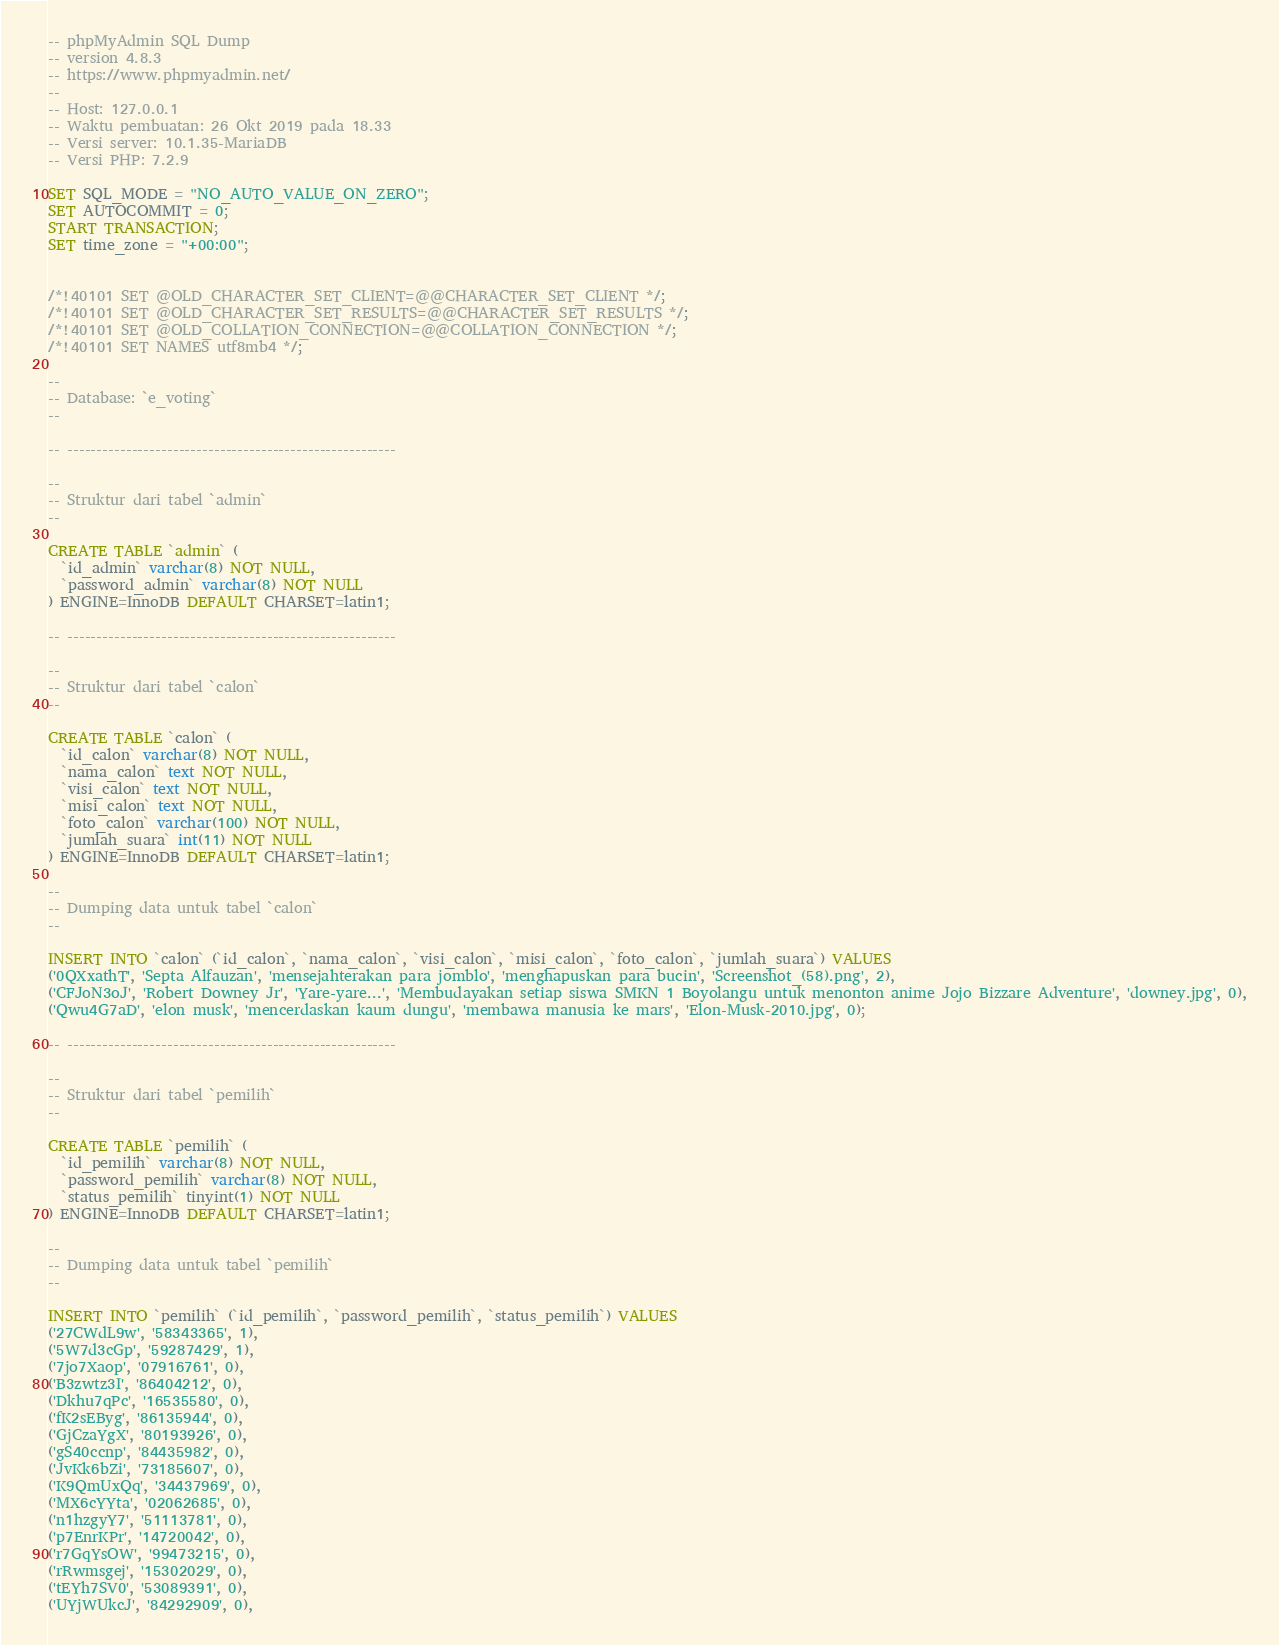Convert code to text. <code><loc_0><loc_0><loc_500><loc_500><_SQL_>-- phpMyAdmin SQL Dump
-- version 4.8.3
-- https://www.phpmyadmin.net/
--
-- Host: 127.0.0.1
-- Waktu pembuatan: 26 Okt 2019 pada 18.33
-- Versi server: 10.1.35-MariaDB
-- Versi PHP: 7.2.9

SET SQL_MODE = "NO_AUTO_VALUE_ON_ZERO";
SET AUTOCOMMIT = 0;
START TRANSACTION;
SET time_zone = "+00:00";


/*!40101 SET @OLD_CHARACTER_SET_CLIENT=@@CHARACTER_SET_CLIENT */;
/*!40101 SET @OLD_CHARACTER_SET_RESULTS=@@CHARACTER_SET_RESULTS */;
/*!40101 SET @OLD_COLLATION_CONNECTION=@@COLLATION_CONNECTION */;
/*!40101 SET NAMES utf8mb4 */;

--
-- Database: `e_voting`
--

-- --------------------------------------------------------

--
-- Struktur dari tabel `admin`
--

CREATE TABLE `admin` (
  `id_admin` varchar(8) NOT NULL,
  `password_admin` varchar(8) NOT NULL
) ENGINE=InnoDB DEFAULT CHARSET=latin1;

-- --------------------------------------------------------

--
-- Struktur dari tabel `calon`
--

CREATE TABLE `calon` (
  `id_calon` varchar(8) NOT NULL,
  `nama_calon` text NOT NULL,
  `visi_calon` text NOT NULL,
  `misi_calon` text NOT NULL,
  `foto_calon` varchar(100) NOT NULL,
  `jumlah_suara` int(11) NOT NULL
) ENGINE=InnoDB DEFAULT CHARSET=latin1;

--
-- Dumping data untuk tabel `calon`
--

INSERT INTO `calon` (`id_calon`, `nama_calon`, `visi_calon`, `misi_calon`, `foto_calon`, `jumlah_suara`) VALUES
('0QXxathT', 'Septa Alfauzan', 'mensejahterakan para jomblo', 'menghapuskan para bucin', 'Screenshot_(58).png', 2),
('CFJoN3oJ', 'Robert Downey Jr', 'Yare-yare...', 'Membudayakan setiap siswa SMKN 1 Boyolangu untuk menonton anime Jojo Bizzare Adventure', 'downey.jpg', 0),
('Qwu4G7aD', 'elon musk', 'mencerdaskan kaum dungu', 'membawa manusia ke mars', 'Elon-Musk-2010.jpg', 0);

-- --------------------------------------------------------

--
-- Struktur dari tabel `pemilih`
--

CREATE TABLE `pemilih` (
  `id_pemilih` varchar(8) NOT NULL,
  `password_pemilih` varchar(8) NOT NULL,
  `status_pemilih` tinyint(1) NOT NULL
) ENGINE=InnoDB DEFAULT CHARSET=latin1;

--
-- Dumping data untuk tabel `pemilih`
--

INSERT INTO `pemilih` (`id_pemilih`, `password_pemilih`, `status_pemilih`) VALUES
('27CWdL9w', '58343365', 1),
('5W7d3cGp', '59287429', 1),
('7jo7Xaop', '07916761', 0),
('B3zwtz3I', '86404212', 0),
('Dkhu7qPc', '16535580', 0),
('fK2sEByg', '86135944', 0),
('GjCzaYgX', '80193926', 0),
('gS40ccnp', '84435982', 0),
('JvKk6bZi', '73185607', 0),
('K9QmUxQq', '34437969', 0),
('MX6cYYta', '02062685', 0),
('n1hzgyY7', '51113781', 0),
('p7EnrKPr', '14720042', 0),
('r7GqYsOW', '99473215', 0),
('rRwmsgej', '15302029', 0),
('tEYh7SV0', '53089391', 0),
('UYjWUkcJ', '84292909', 0),</code> 